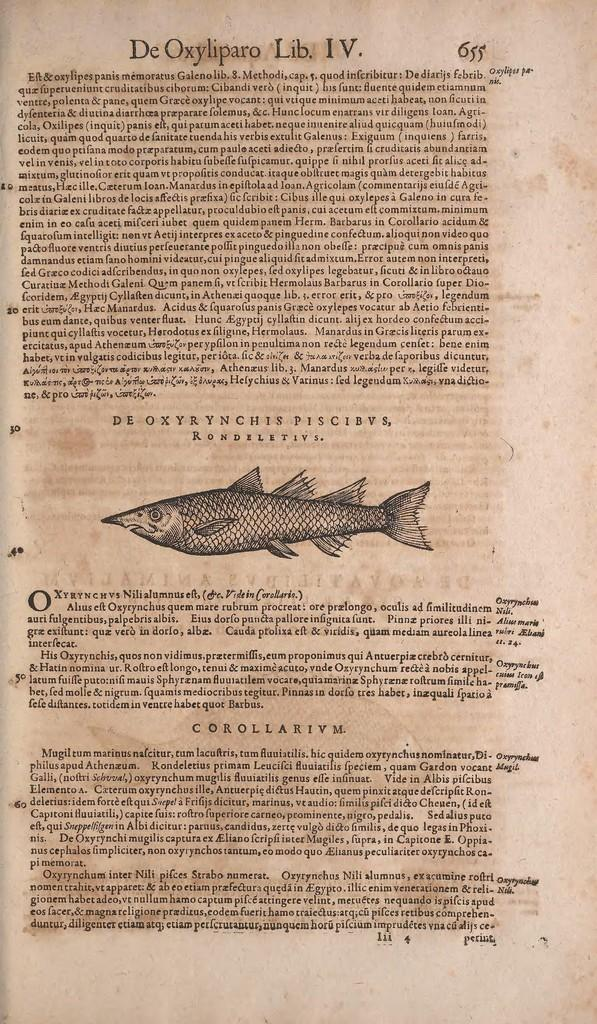What is present on the paper in the image? The paper contains letters and a picture of a fish. Can you describe the picture on the paper? The picture on the paper is of a fish. What type of sign is present in the image? There is no sign present in the image; it only contains a paper with letters and a picture of a fish. What riddle can be solved using the information in the image? There is no riddle present in the image; it only contains a paper with letters and a picture of a fish. 